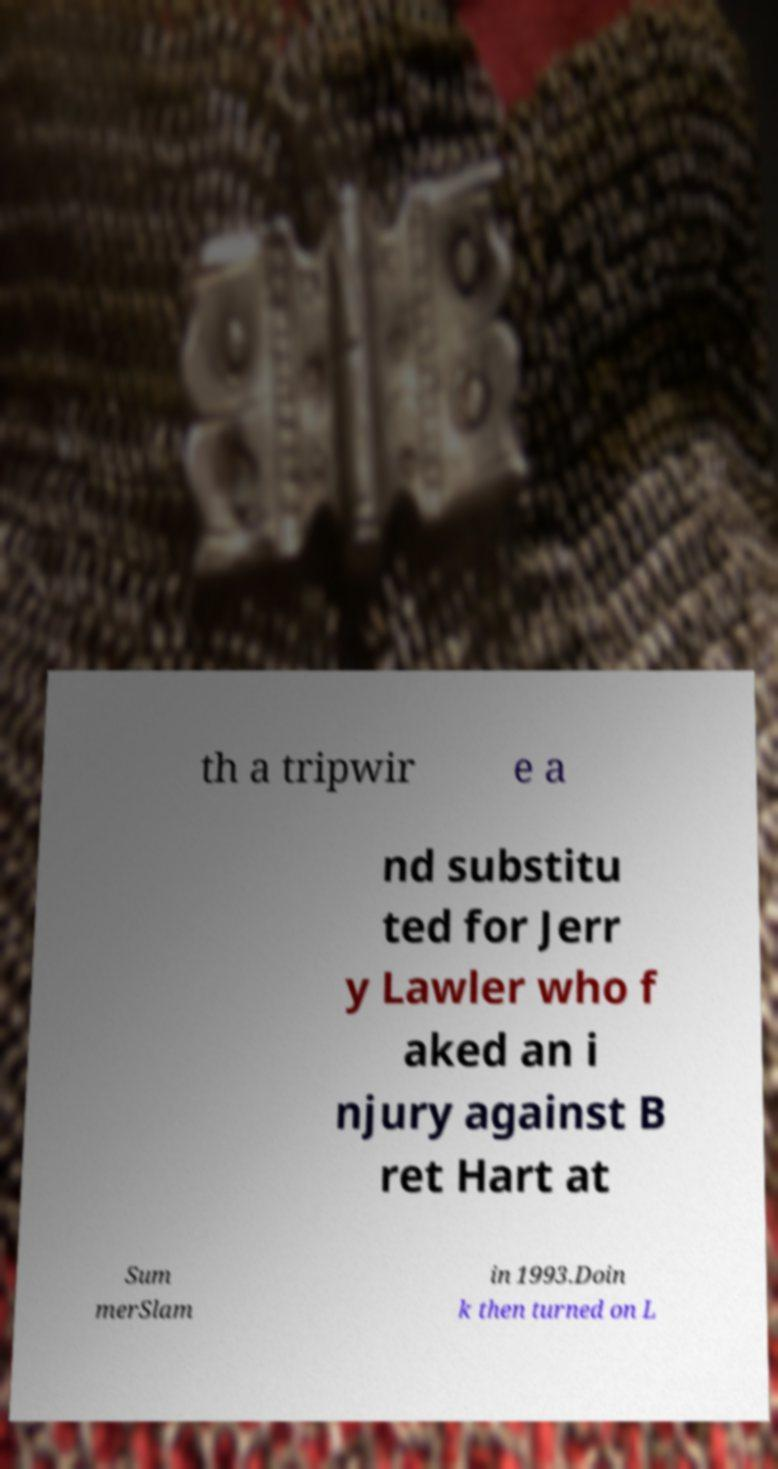Please identify and transcribe the text found in this image. th a tripwir e a nd substitu ted for Jerr y Lawler who f aked an i njury against B ret Hart at Sum merSlam in 1993.Doin k then turned on L 